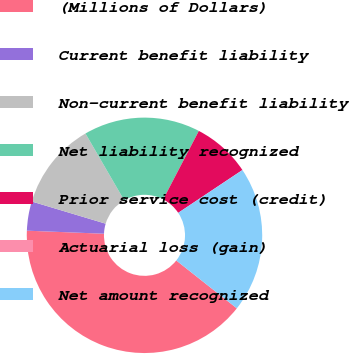Convert chart to OTSL. <chart><loc_0><loc_0><loc_500><loc_500><pie_chart><fcel>(Millions of Dollars)<fcel>Current benefit liability<fcel>Non-current benefit liability<fcel>Net liability recognized<fcel>Prior service cost (credit)<fcel>Actuarial loss (gain)<fcel>Net amount recognized<nl><fcel>39.98%<fcel>4.01%<fcel>12.0%<fcel>16.0%<fcel>8.0%<fcel>0.01%<fcel>20.0%<nl></chart> 